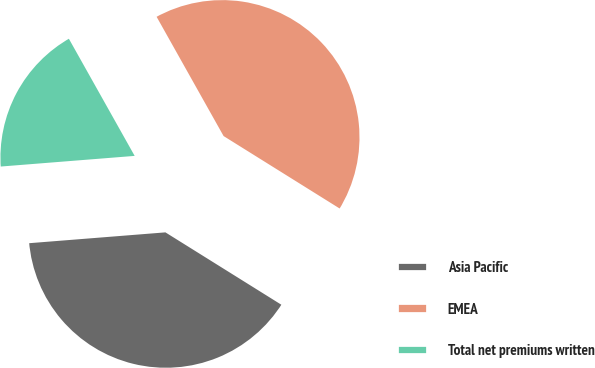<chart> <loc_0><loc_0><loc_500><loc_500><pie_chart><fcel>Asia Pacific<fcel>EMEA<fcel>Total net premiums written<nl><fcel>39.86%<fcel>42.03%<fcel>18.12%<nl></chart> 